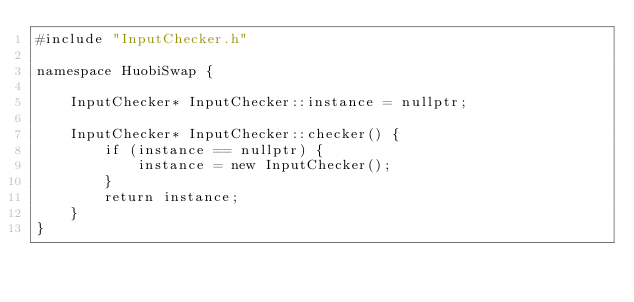Convert code to text. <code><loc_0><loc_0><loc_500><loc_500><_C++_>#include "InputChecker.h"

namespace HuobiSwap {

    InputChecker* InputChecker::instance = nullptr;

    InputChecker* InputChecker::checker() {
        if (instance == nullptr) {
            instance = new InputChecker();
        }
        return instance;
    }
}
</code> 